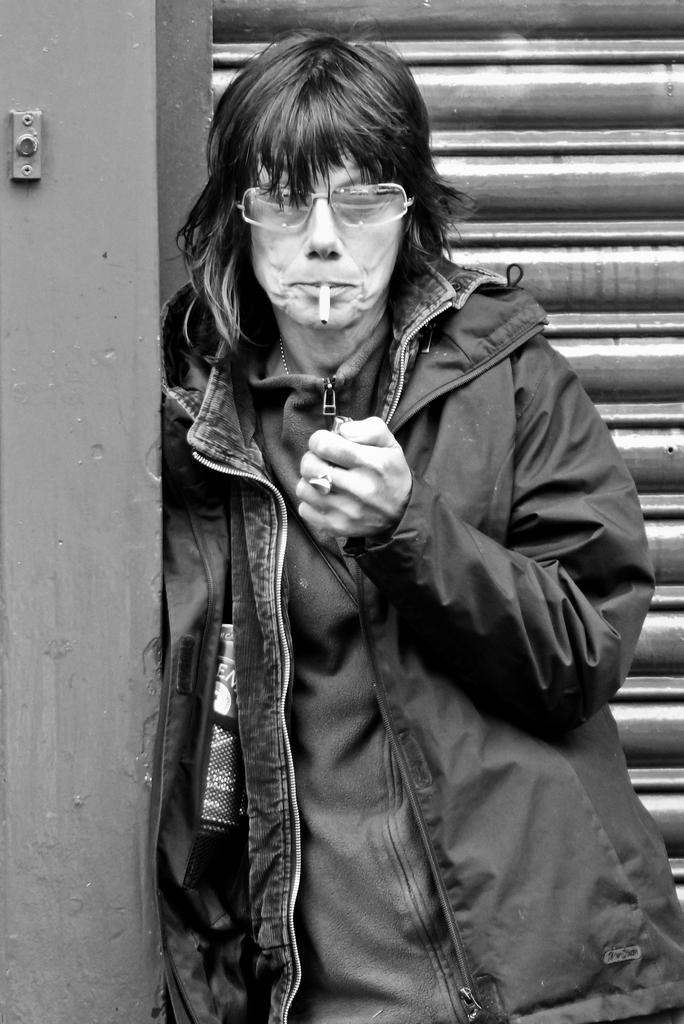What is the person in the image doing near the pillar? The person is standing near a pillar in the image. Can you describe the person's appearance? The person is wearing spectacles. What is the person holding in his hand? The person is holding a lighter. What is the person doing with the cigarette in his mouth? The person has a cigarette in his mouth. What can be seen in the background of the image? There is a shutter in the background of the image. How many ghosts are present in the image? There are no ghosts present in the image. What type of cookware is the cook using in the image? There is no cook or cookware present in the image. What is the value of the cent in the image? There is no cent present in the image. 